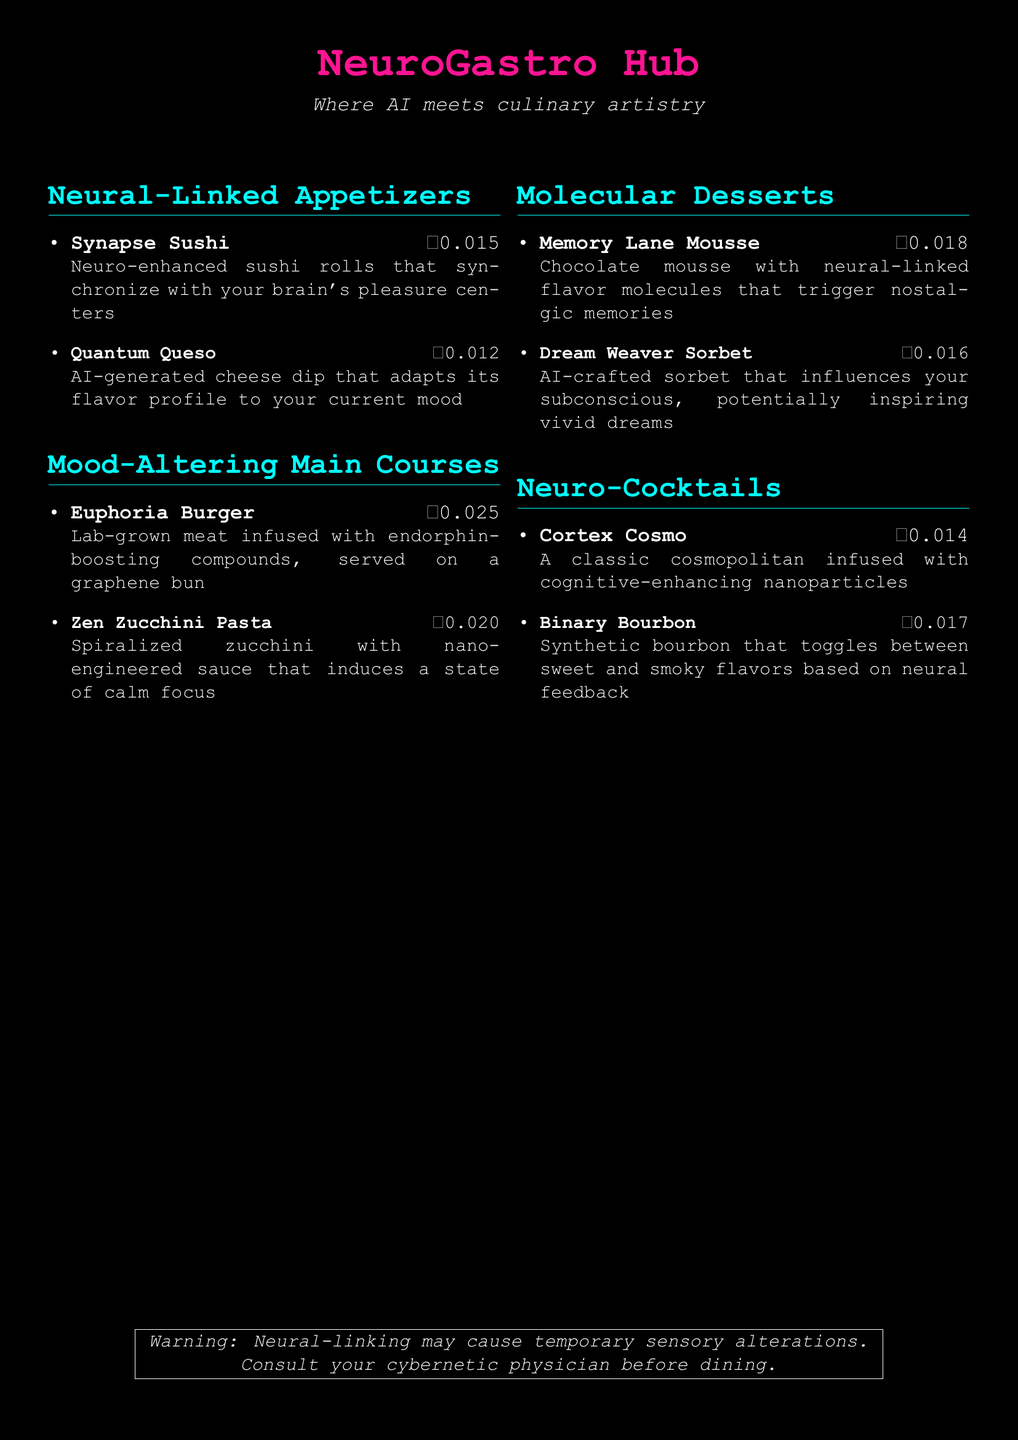what is the name of the restaurant? The name of the restaurant is prominently featured at the top of the document.
Answer: NeuroGastro Hub what color is the title of the menu? The menu title is colored in a distinct cyberpunk shade, which is highlighted in the document.
Answer: cyberpunk how much does the Euphoria Burger cost? The cost of the Euphoria Burger is listed next to its name under the menu section.
Answer: ₿0.025 which appetizer features AI-generated cheese? The appetizer is named in the Neural-Linked Appetizers section.
Answer: Quantum Queso what is a key ingredient in the Dream Weaver Sorbet? The dessert's description mentions its influence on the subconscious, indicating a unique culinary component.
Answer: AI-crafted how many main courses are offered on the menu? The number of main courses can be calculated from the list of items in that section.
Answer: 2 what warning is provided about neural-linking? The warning text is included in a framed box at the bottom of the document.
Answer: Neural-linking may cause temporary sensory alterations which cocktail uses nanoparticles? The cocktail's name and its description indicate its special ingredient related to cognitive enhancement.
Answer: Cortex Cosmo 